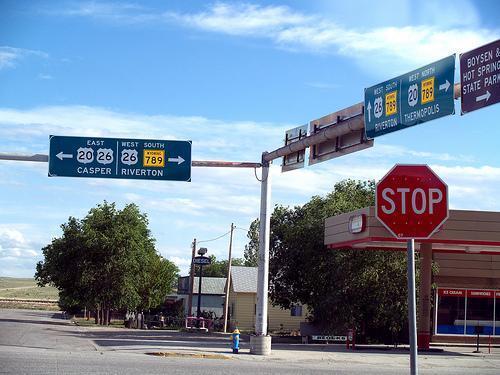How many stop signs are in the picture?
Give a very brief answer. 1. 